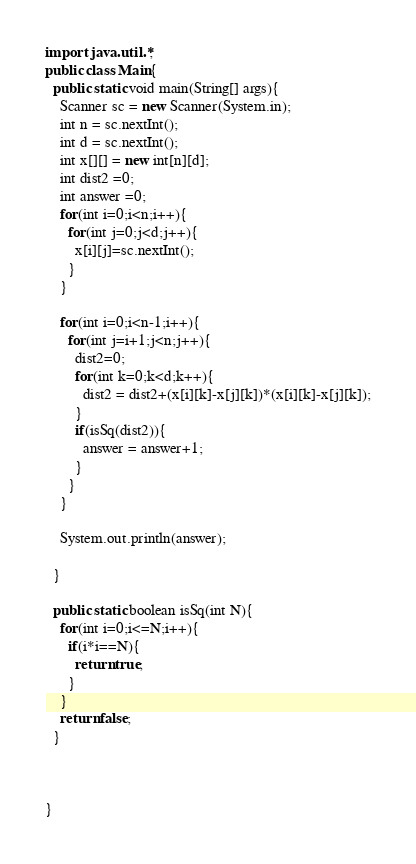<code> <loc_0><loc_0><loc_500><loc_500><_Java_>import java.util.*;
public class Main{
  public static void main(String[] args){
    Scanner sc = new Scanner(System.in);
    int n = sc.nextInt();
    int d = sc.nextInt();
    int x[][] = new int[n][d];
    int dist2 =0;
    int answer =0;
    for(int i=0;i<n;i++){
      for(int j=0;j<d;j++){
        x[i][j]=sc.nextInt();
      }
    }
    
    for(int i=0;i<n-1;i++){
      for(int j=i+1;j<n;j++){
        dist2=0;
        for(int k=0;k<d;k++){
          dist2 = dist2+(x[i][k]-x[j][k])*(x[i][k]-x[j][k]);
        }
        if(isSq(dist2)){
          answer = answer+1;
        }
      }
    }
        
    System.out.println(answer);
       
  }
  
  public static boolean isSq(int N){
    for(int i=0;i<=N;i++){
      if(i*i==N){
        return true;
      }
    }
    return false;
  }
  

  
}</code> 